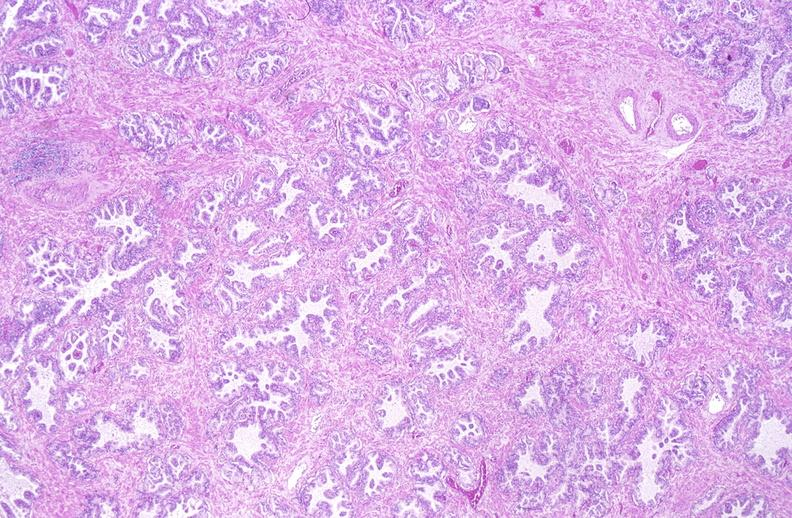does this image show normal prostate?
Answer the question using a single word or phrase. Yes 